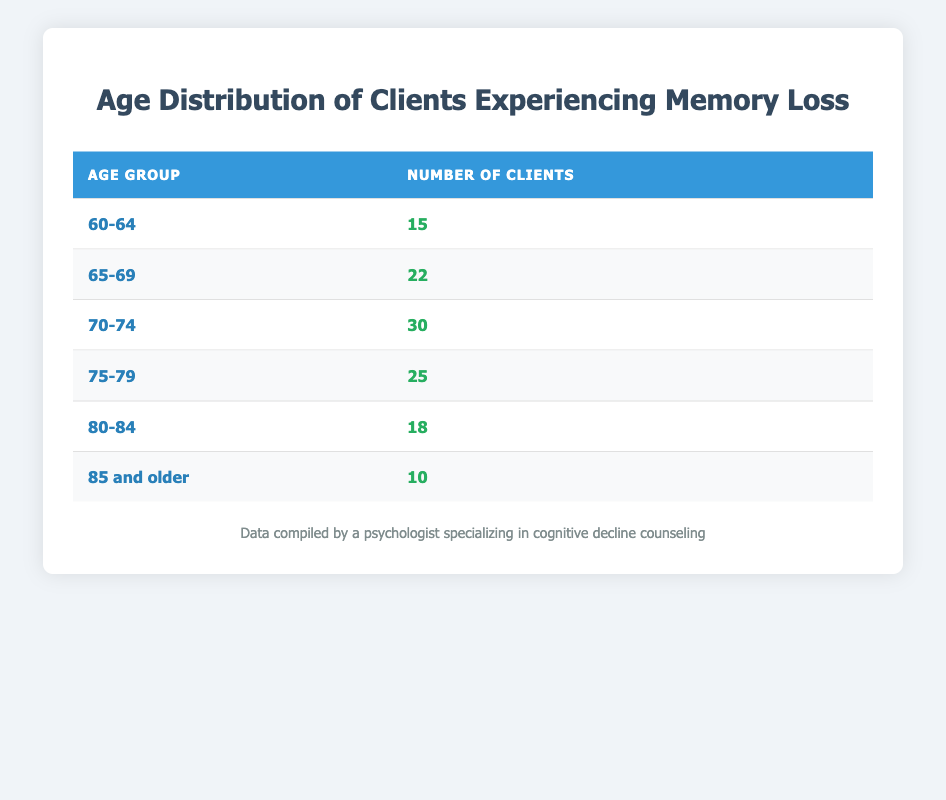What age group has the highest number of clients experiencing memory loss? The age group with the highest number of clients is "70-74" with 30 clients. This can be easily identified by looking for the row with the greatest value under the "Number of Clients" column.
Answer: 70-74 How many clients aged 75 and older are experiencing memory loss? To find this, I need to add the number of clients from the "75-79" age group (25) and the "85 and older" age group (10). So, 25 + 10 = 35.
Answer: 35 What is the total number of clients in the 60-64 and 80-84 age groups? The count of clients in the "60-64" group is 15 and in the "80-84" group is 18. Adding them provides the total: 15 + 18 = 33.
Answer: 33 Is it true that more clients aged 75-79 than those aged 85 and older are experiencing memory loss? The "75-79" group has 25 clients while the "85 and older" group has 10 clients. Since 25 is greater than 10, the statement is true.
Answer: Yes What is the average number of clients experiencing memory loss across all age groups? First, I sum all the clients: 15 + 22 + 30 + 25 + 18 + 10 = 120. Next, I divide this total by the number of age groups, which is 6: 120 / 6 = 20. So the average is 20.
Answer: 20 Which age group has the lowest number of clients experiencing memory loss? By examining the table, it is clear that the "85 and older" group has the lowest count of 10 clients. This is identified by looking for the row with the smallest value in the "Number of Clients" column.
Answer: 85 and older What percentage of the total clients does the 70-74 age group represent? Firstly, I determine the total number of clients, which is 120. The number of clients in the "70-74" age group is 30. Then I calculate the percentage: (30 / 120) * 100 = 25%.
Answer: 25% How many clients are there from age groups under 70? The relevant age groups are "60-64" (15 clients) and "65-69" (22 clients). Summing these gives: 15 + 22 = 37 clients under age 70.
Answer: 37 